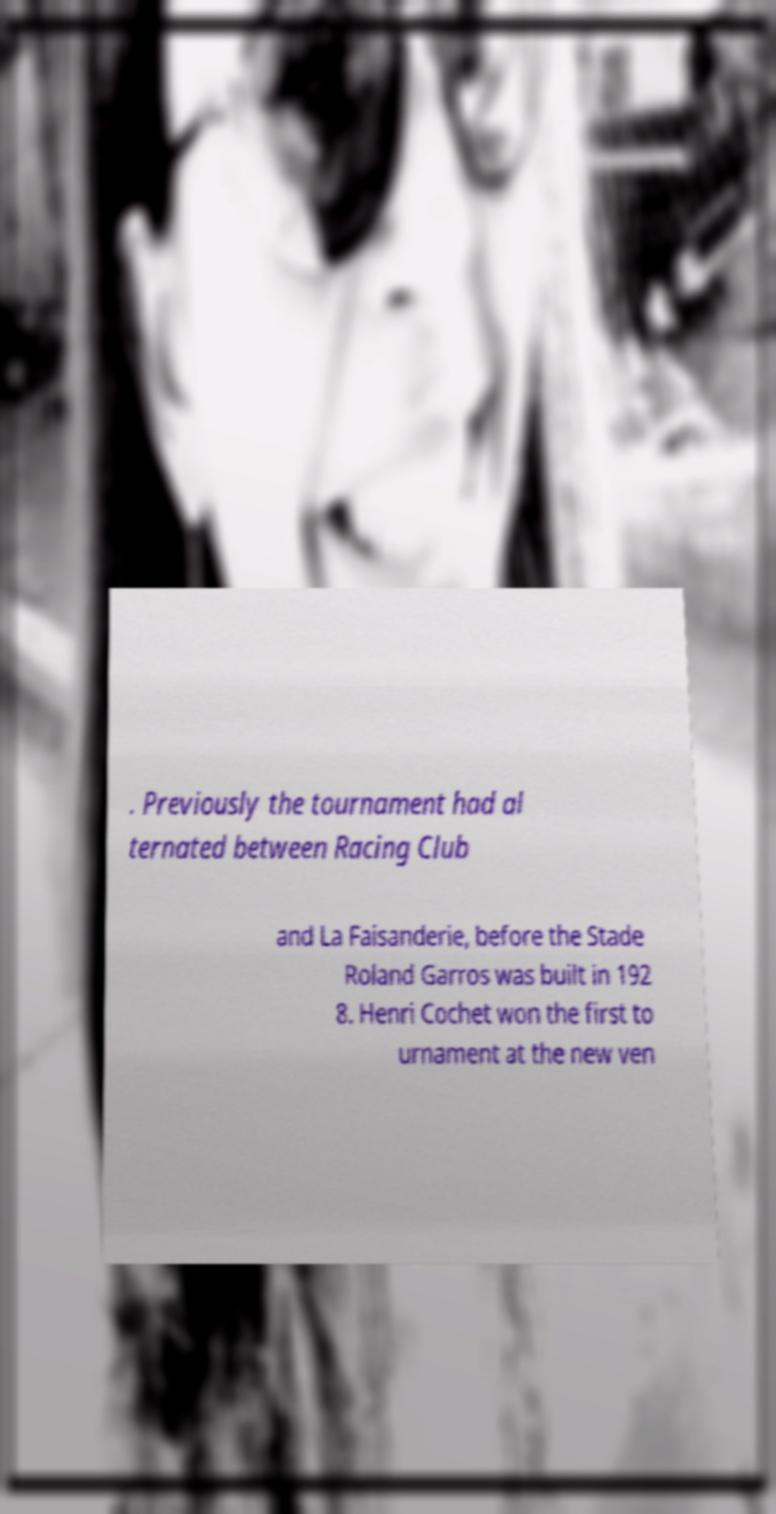For documentation purposes, I need the text within this image transcribed. Could you provide that? . Previously the tournament had al ternated between Racing Club and La Faisanderie, before the Stade Roland Garros was built in 192 8. Henri Cochet won the first to urnament at the new ven 